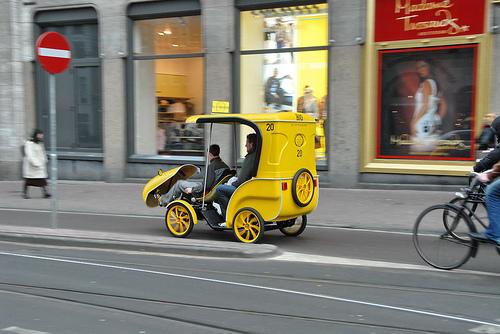How many wheels does the bike in the forefront of the picture have?
Quick response, please. 4. What are these people riding?
Keep it brief. Taxi. Is this person riding a motorcycle or a bicycle?
Short answer required. Bicycle. What is the name of the store?
Write a very short answer. Madame tussauds. Does the yellow car have a motor?
Keep it brief. No. What season is it on the picture in the window?
Give a very brief answer. Winter. What is the man riding?
Write a very short answer. Cart. What type of vehicle is this?
Write a very short answer. Cart. What is the purpose of the red sign?
Be succinct. No entry. How many people are walking on the sidewalk?
Write a very short answer. 1. Is she standing outside or inside?
Quick response, please. Outside. Is this a motorcycle?
Short answer required. No. Is the rickshaw free?
Give a very brief answer. No. What color is the taxi cab?
Concise answer only. Yellow. 